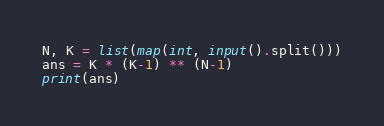Convert code to text. <code><loc_0><loc_0><loc_500><loc_500><_Python_>N, K = list(map(int, input().split()))
ans = K * (K-1) ** (N-1)
print(ans)</code> 